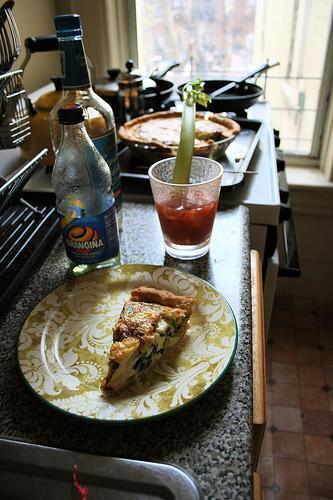How many plates are served?
Give a very brief answer. 1. How many slices of pie are cut?
Give a very brief answer. 1. How many bottles are on the counter?
Give a very brief answer. 2. How many frying pans are on the stove?
Give a very brief answer. 2. 